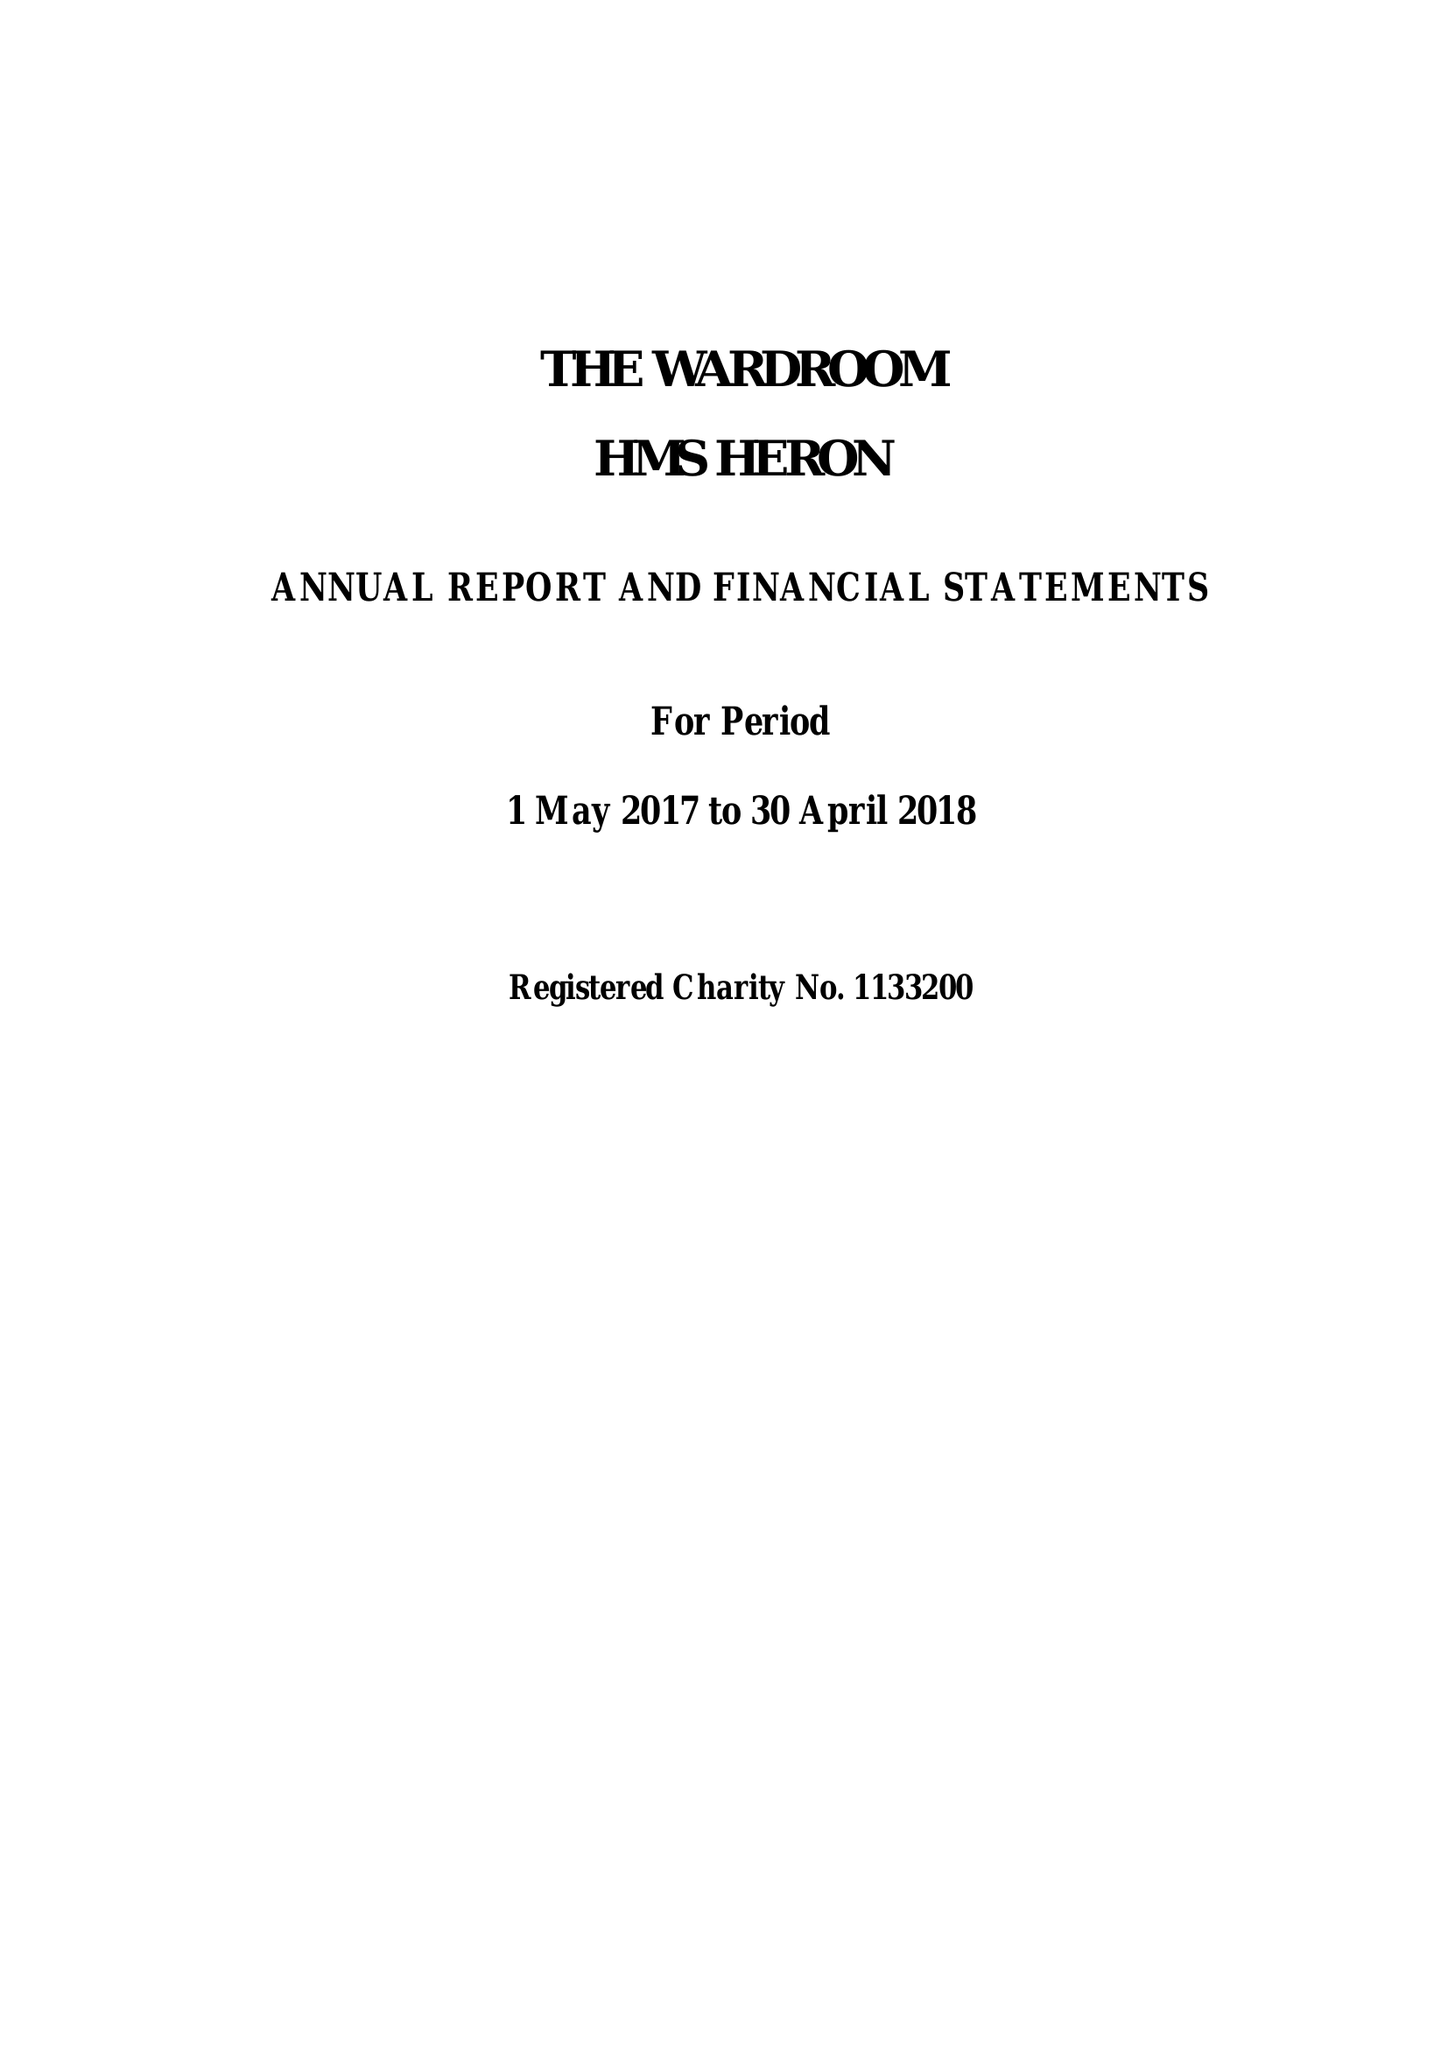What is the value for the income_annually_in_british_pounds?
Answer the question using a single word or phrase. 248113.00 